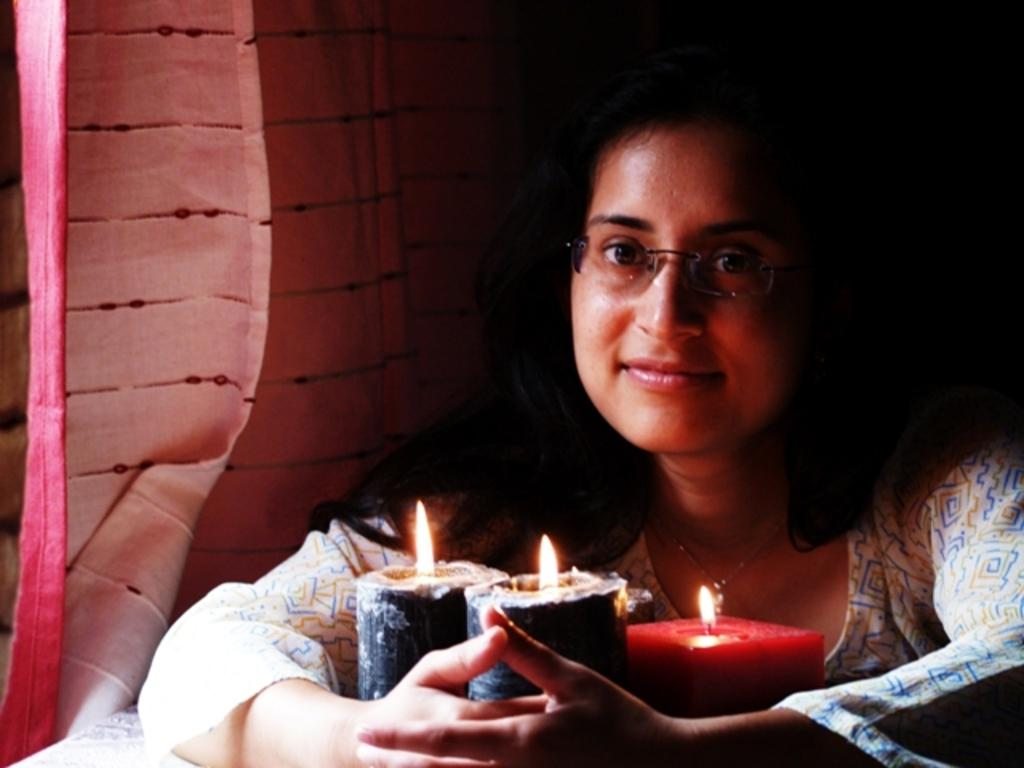Who is present in the image? There is a lady in the image. What accessory is the lady wearing? The lady is wearing glasses. What objects can be seen at the bottom of the image? There are candles at the bottom of the image. What can be seen in the background of the image? There is a curtain in the background of the image. What type of apparatus is the lady using to levitate in the image? There is no apparatus present in the image, and the lady is not levitating. How many cakes are visible on the table in the image? There is no table or cakes present in the image. Are there any spiders crawling on the lady in the image? There are no spiders present in the image. 